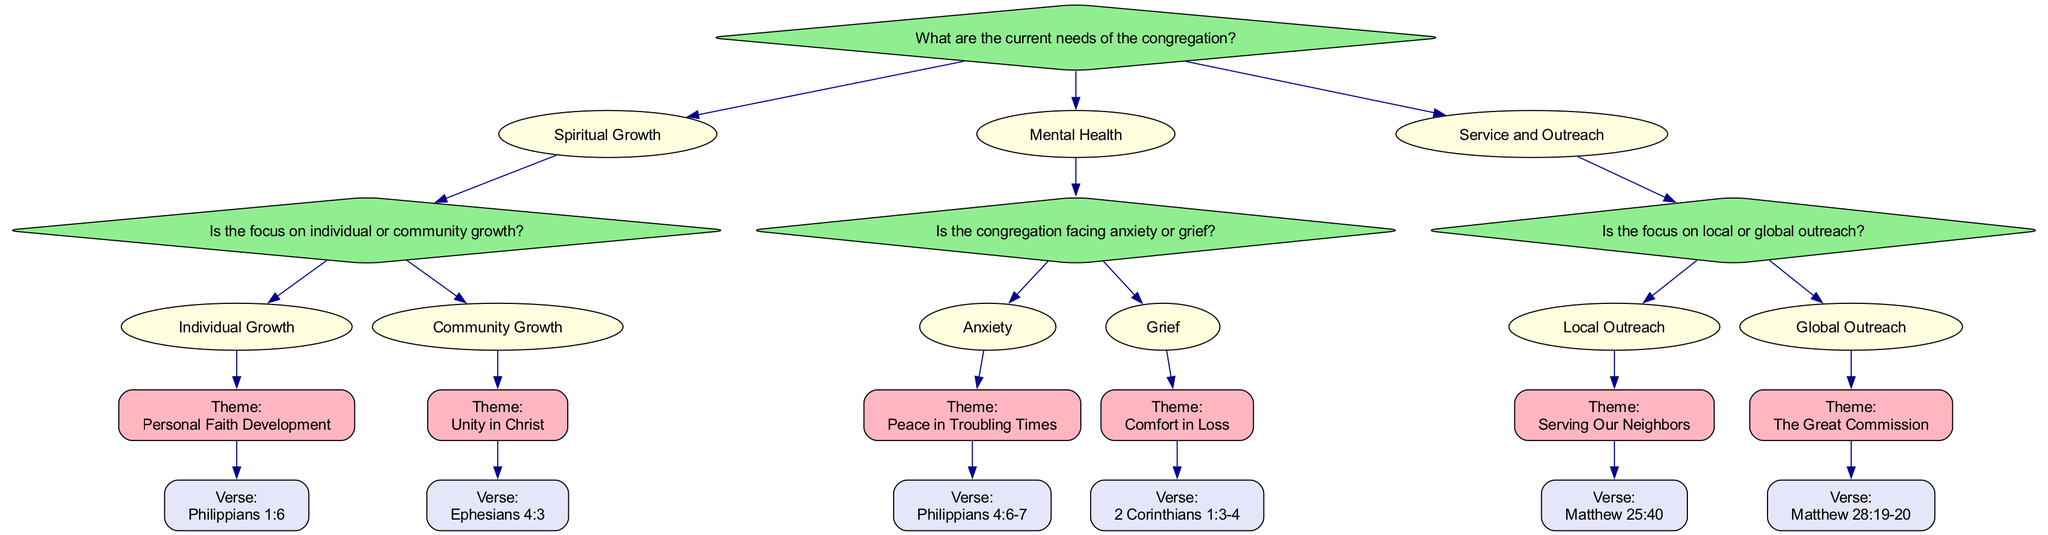What is the initial question posed in the decision tree? The first node in the decision tree presents the main question which is focused on understanding the congregation's needs.
Answer: What are the current needs of the congregation? How many main options does the decision tree provide after the initial question? Following the initial question, there are three primary options outlined: Spiritual Growth, Mental Health, and Service and Outreach. This can be counted directly from the nodes under the initial question.
Answer: Three What theme is associated with the verse Philippians 4:6-7? To find this, you trace down the "Mental Health" option, then to "Anxiety" within the options, which leads to the theme "Peace in Troubling Times" that corresponds to the verse Philippians 4:6-7.
Answer: Peace in Troubling Times Which option leads to the theme "Unity in Christ"? The path to this theme is found by moving from the "Spiritual Growth" option to "Community Growth," which leads to the specific theme of "Unity in Christ."
Answer: Community Growth What are the final nodes under the "Local Outreach" option? For this question, you follow the "Service and Outreach" option, then go to "Local Outreach;" the last nodes under this option are the theme "Serving Our Neighbors" and the verse "Matthew 25:40."
Answer: Serving Our Neighbors and Matthew 25:40 Which theme is linked to "The Great Commission"? This information is discovered by tracing the "Service and Outreach" branch to the "Global Outreach" option, which links to the theme "The Great Commission."
Answer: The Great Commission If a congregation is focusing on individual growth, which Bible verse should they align with? The decision path would go from "Spiritual Growth" to "Individual Growth," leading to the specific verse associated with the theme "Personal Faith Development," which is Philippians 1:6.
Answer: Philippians 1:6 What are the two mental health focus areas identified in the decision tree? The decision tree highlights two focus areas under "Mental Health": "Anxiety" and "Grief," which can be identified from the listed options under that main category.
Answer: Anxiety and Grief 